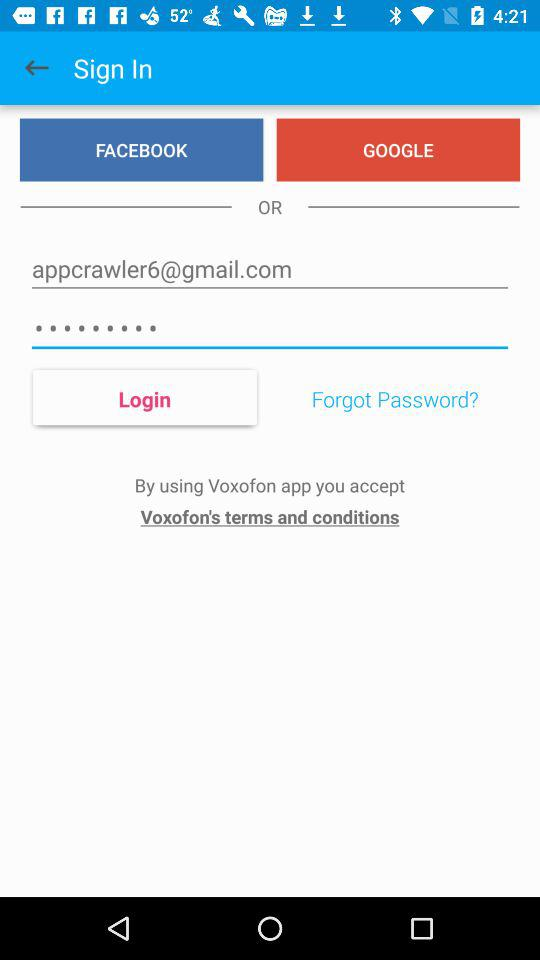What's the Google mail address used by the user to log in? The Google mail address is appcrawler6@gmail.com. 